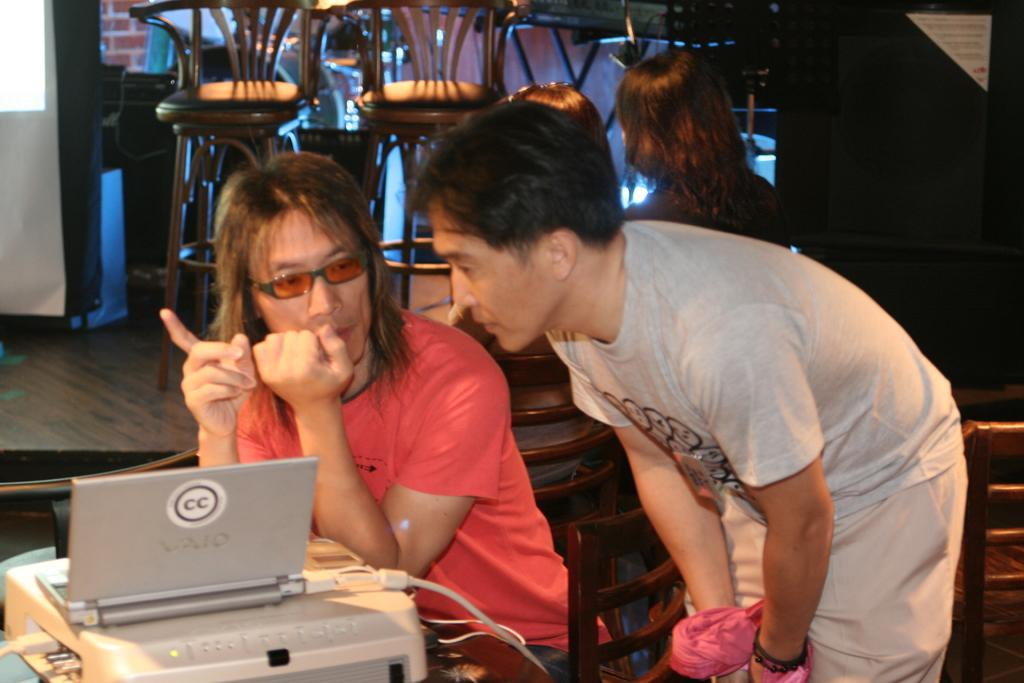<image>
Write a terse but informative summary of the picture. A small silver laptop with CC on the lid sits in front of a man in red. 